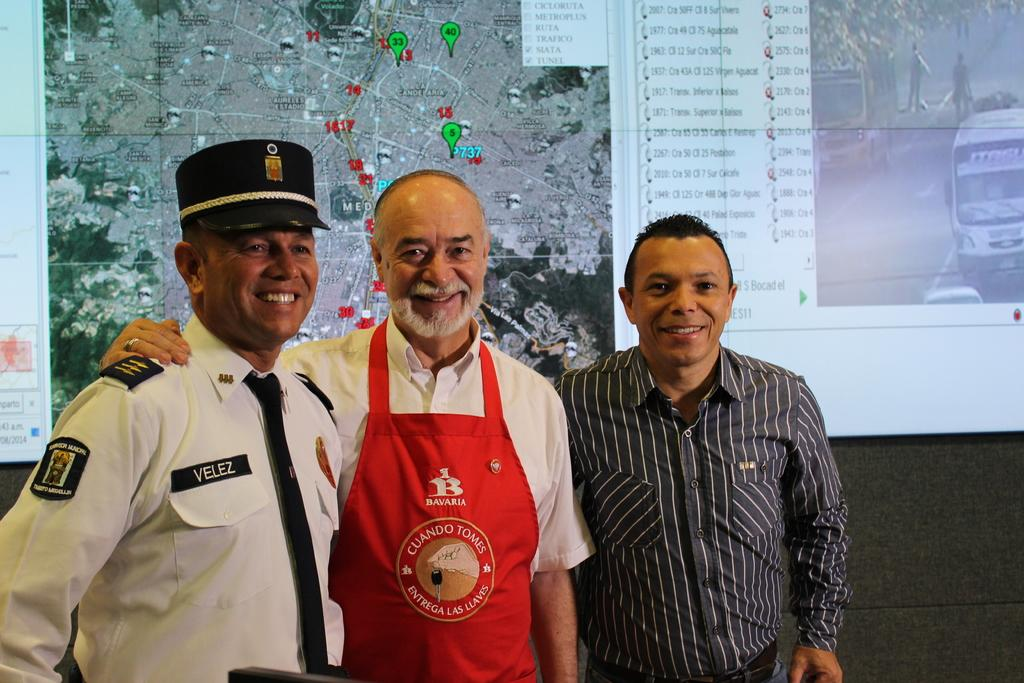<image>
Render a clear and concise summary of the photo. the man on the left is Mr. Velez 